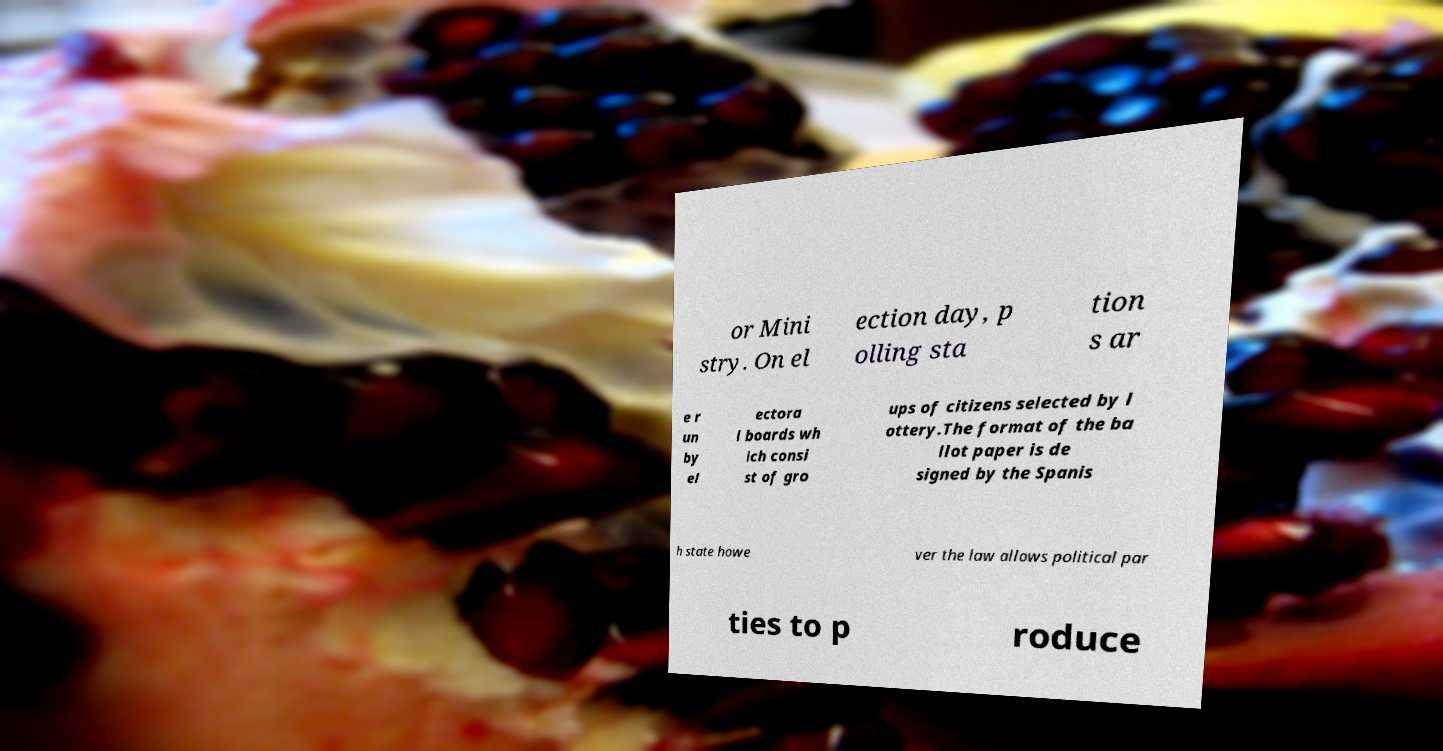Can you accurately transcribe the text from the provided image for me? or Mini stry. On el ection day, p olling sta tion s ar e r un by el ectora l boards wh ich consi st of gro ups of citizens selected by l ottery.The format of the ba llot paper is de signed by the Spanis h state howe ver the law allows political par ties to p roduce 